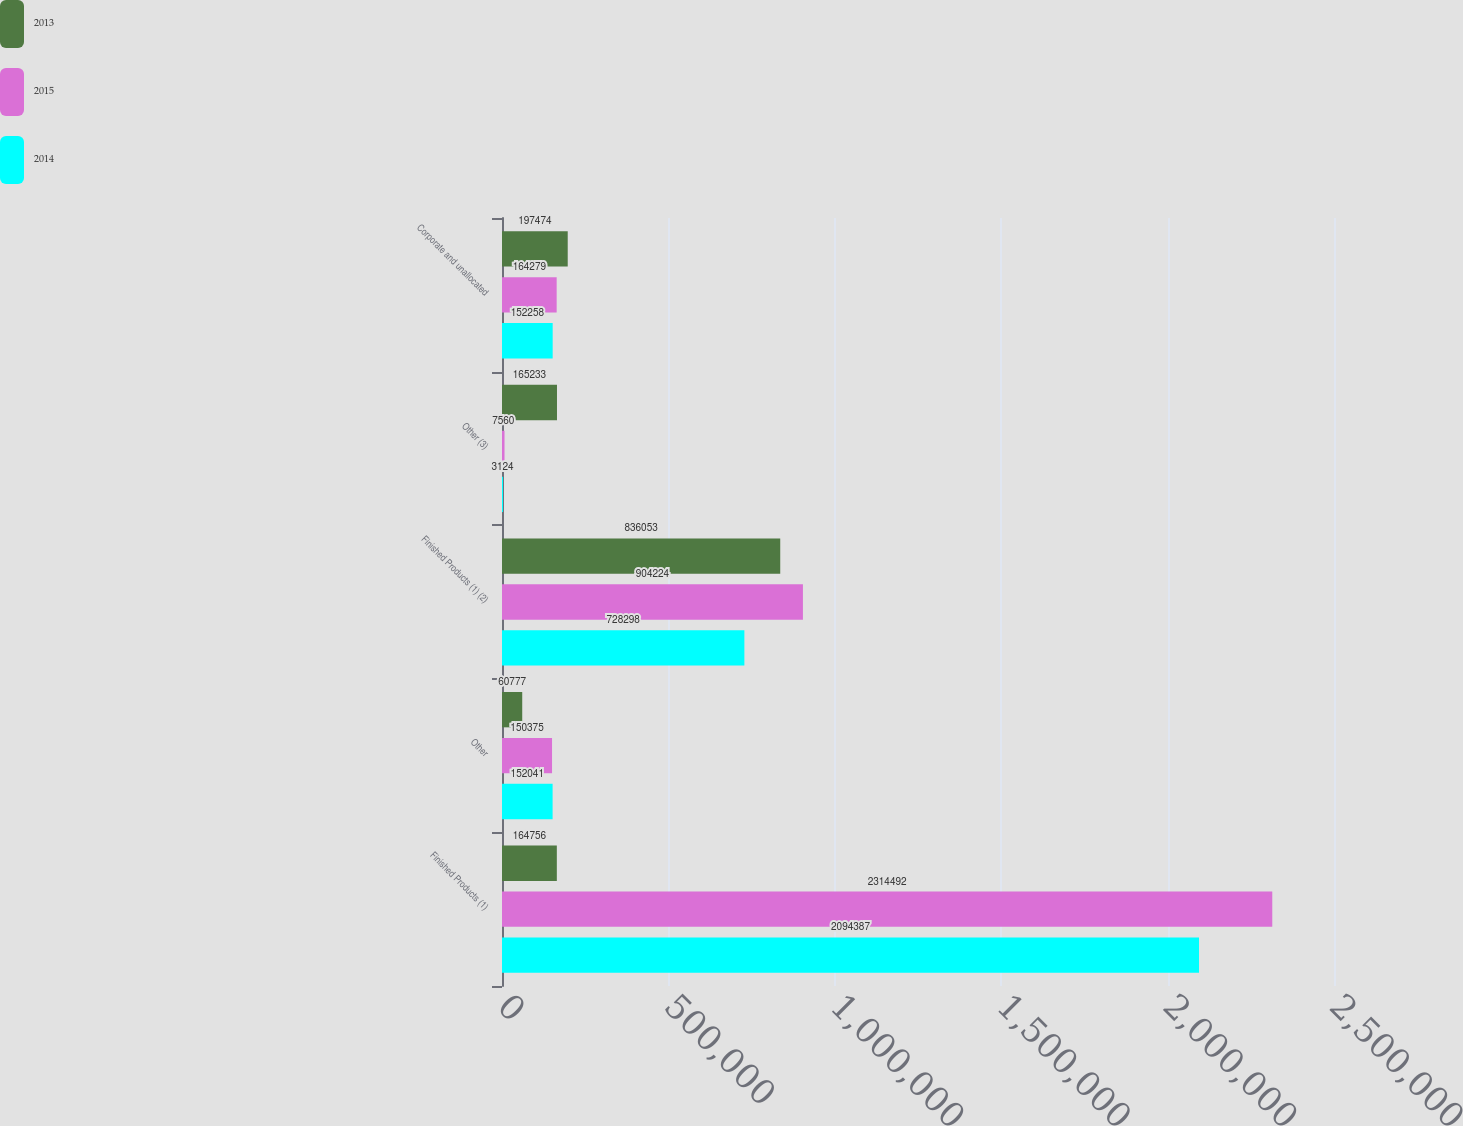Convert chart to OTSL. <chart><loc_0><loc_0><loc_500><loc_500><stacked_bar_chart><ecel><fcel>Finished Products (1)<fcel>Other<fcel>Finished Products (1) (2)<fcel>Other (3)<fcel>Corporate and unallocated<nl><fcel>2013<fcel>164756<fcel>60777<fcel>836053<fcel>165233<fcel>197474<nl><fcel>2015<fcel>2.31449e+06<fcel>150375<fcel>904224<fcel>7560<fcel>164279<nl><fcel>2014<fcel>2.09439e+06<fcel>152041<fcel>728298<fcel>3124<fcel>152258<nl></chart> 